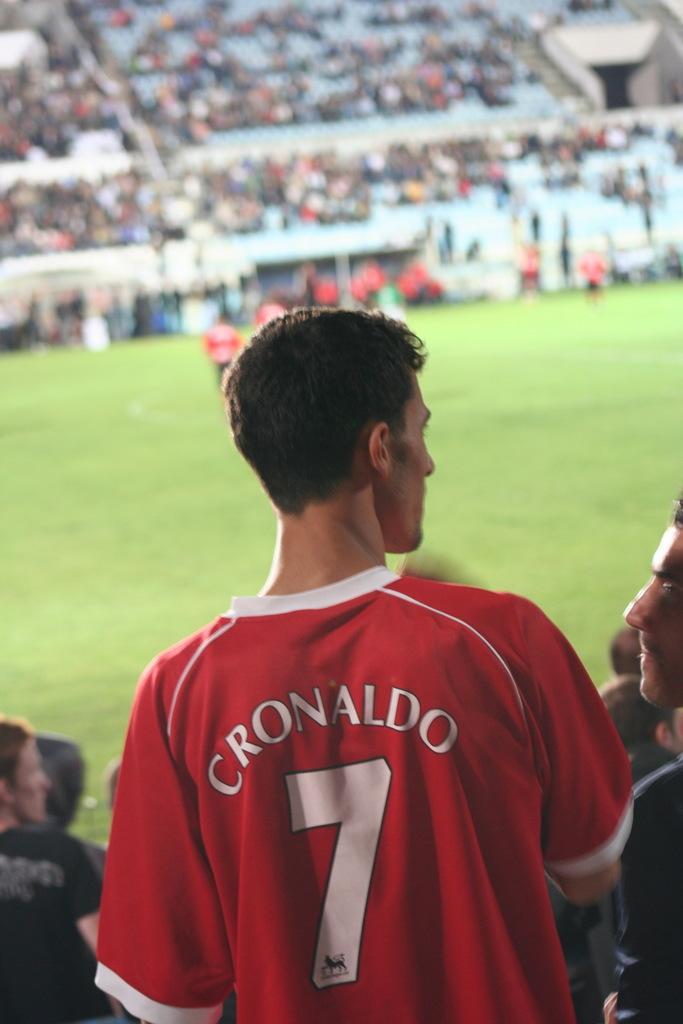<image>
Share a concise interpretation of the image provided. A young man in a red Cronaldo Jersey stands looking at someone by a soccer field. 